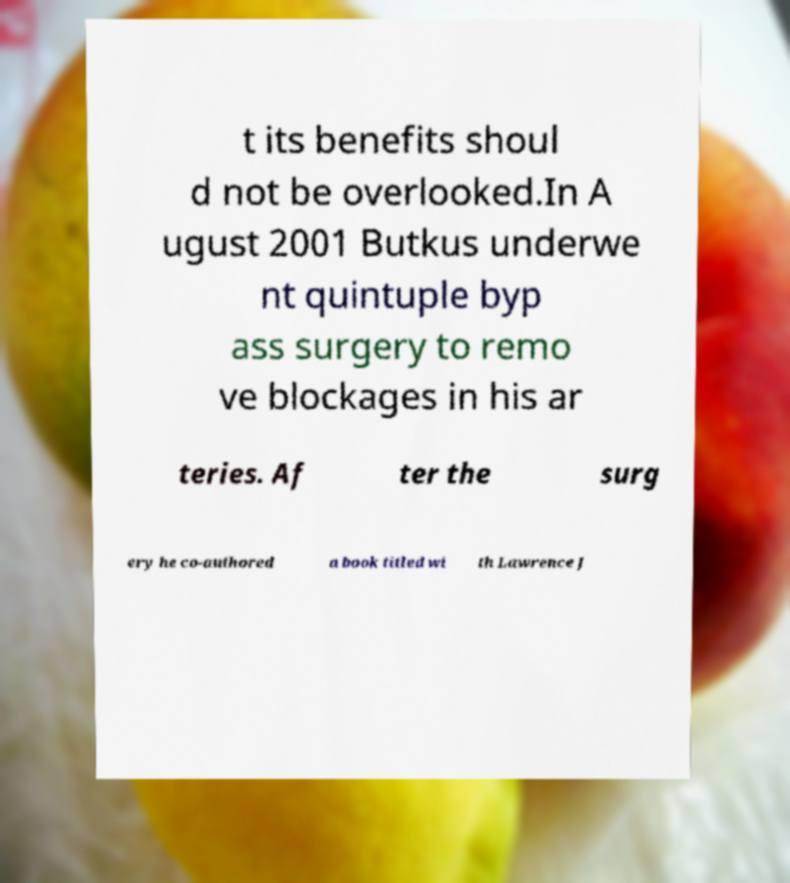Can you read and provide the text displayed in the image?This photo seems to have some interesting text. Can you extract and type it out for me? t its benefits shoul d not be overlooked.In A ugust 2001 Butkus underwe nt quintuple byp ass surgery to remo ve blockages in his ar teries. Af ter the surg ery he co-authored a book titled wi th Lawrence J 